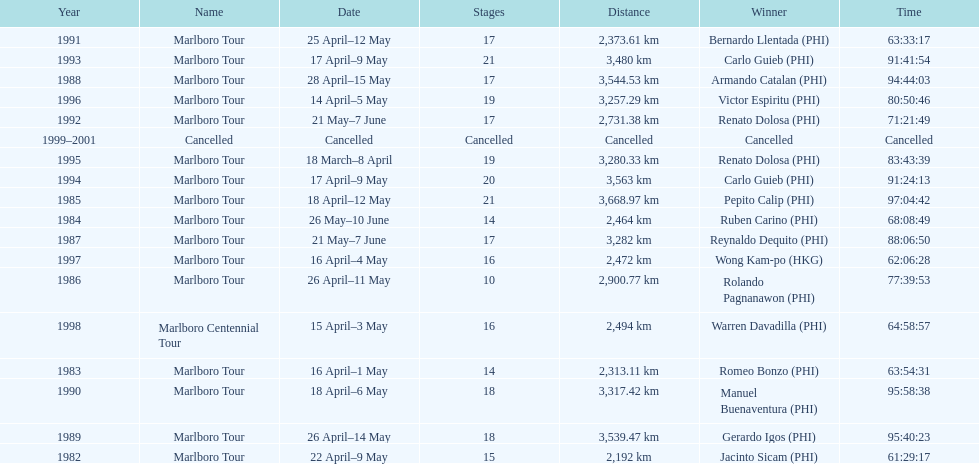Who is listed before wong kam-po? Victor Espiritu (PHI). 